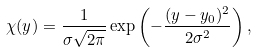<formula> <loc_0><loc_0><loc_500><loc_500>\chi ( y ) = \frac { 1 } { \sigma \sqrt { 2 \pi } } \exp \left ( - \frac { ( y - y _ { 0 } ) ^ { 2 } } { 2 \sigma ^ { 2 } } \right ) ,</formula> 